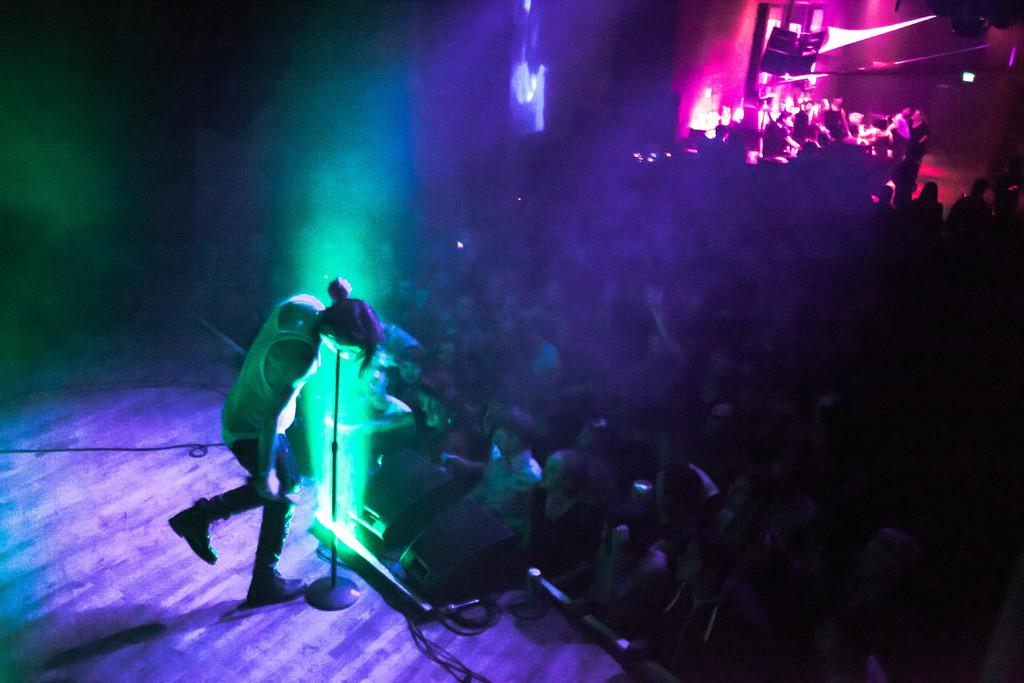What is the main subject of the image? The main subject of the image is a singer. Where is the singer located in the image? The singer is on a stage. What else can be seen in the image besides the singer? There is a crowd in the image. How does the singer increase the pleasure of the queen in the image? There is no queen present in the image, and therefore no such interaction can be observed. 